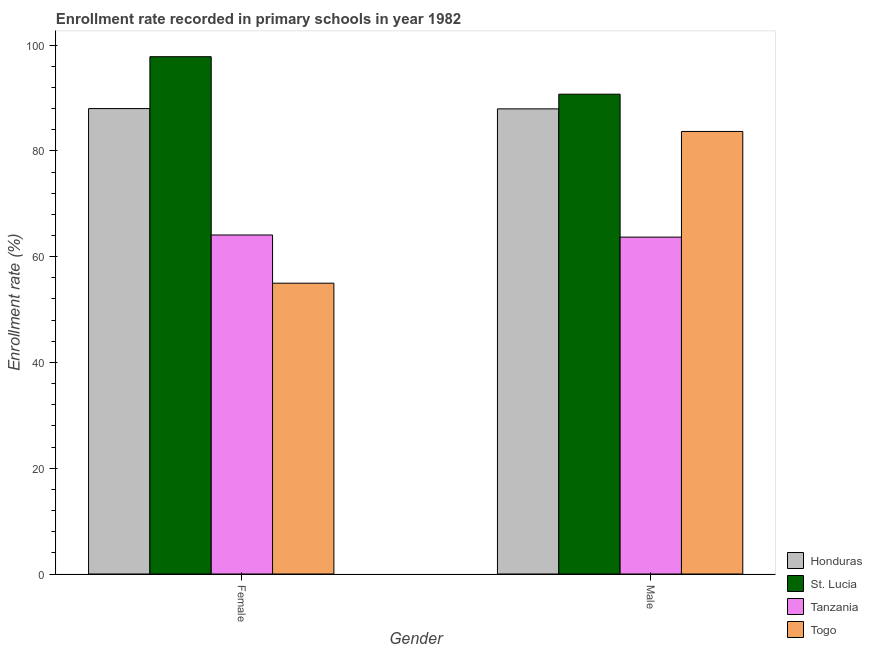Are the number of bars on each tick of the X-axis equal?
Provide a short and direct response. Yes. How many bars are there on the 2nd tick from the right?
Provide a short and direct response. 4. What is the label of the 1st group of bars from the left?
Your answer should be compact. Female. What is the enrollment rate of male students in Honduras?
Give a very brief answer. 87.95. Across all countries, what is the maximum enrollment rate of male students?
Make the answer very short. 90.72. Across all countries, what is the minimum enrollment rate of male students?
Offer a very short reply. 63.7. In which country was the enrollment rate of male students maximum?
Provide a succinct answer. St. Lucia. In which country was the enrollment rate of male students minimum?
Ensure brevity in your answer.  Tanzania. What is the total enrollment rate of male students in the graph?
Ensure brevity in your answer.  326.05. What is the difference between the enrollment rate of female students in St. Lucia and that in Togo?
Your response must be concise. 42.83. What is the difference between the enrollment rate of female students in Togo and the enrollment rate of male students in Honduras?
Make the answer very short. -32.96. What is the average enrollment rate of male students per country?
Offer a very short reply. 81.51. What is the difference between the enrollment rate of female students and enrollment rate of male students in Togo?
Provide a succinct answer. -28.69. What is the ratio of the enrollment rate of male students in Honduras to that in Tanzania?
Keep it short and to the point. 1.38. In how many countries, is the enrollment rate of female students greater than the average enrollment rate of female students taken over all countries?
Offer a very short reply. 2. What does the 4th bar from the left in Male represents?
Offer a terse response. Togo. What does the 4th bar from the right in Male represents?
Offer a very short reply. Honduras. Are all the bars in the graph horizontal?
Make the answer very short. No. How many countries are there in the graph?
Ensure brevity in your answer.  4. Are the values on the major ticks of Y-axis written in scientific E-notation?
Your answer should be compact. No. How many legend labels are there?
Offer a very short reply. 4. What is the title of the graph?
Provide a short and direct response. Enrollment rate recorded in primary schools in year 1982. What is the label or title of the X-axis?
Offer a terse response. Gender. What is the label or title of the Y-axis?
Provide a succinct answer. Enrollment rate (%). What is the Enrollment rate (%) in Honduras in Female?
Provide a short and direct response. 88. What is the Enrollment rate (%) of St. Lucia in Female?
Your answer should be very brief. 97.81. What is the Enrollment rate (%) in Tanzania in Female?
Offer a terse response. 64.1. What is the Enrollment rate (%) in Togo in Female?
Ensure brevity in your answer.  54.99. What is the Enrollment rate (%) in Honduras in Male?
Your response must be concise. 87.95. What is the Enrollment rate (%) in St. Lucia in Male?
Ensure brevity in your answer.  90.72. What is the Enrollment rate (%) in Tanzania in Male?
Ensure brevity in your answer.  63.7. What is the Enrollment rate (%) of Togo in Male?
Provide a short and direct response. 83.68. Across all Gender, what is the maximum Enrollment rate (%) of Honduras?
Your response must be concise. 88. Across all Gender, what is the maximum Enrollment rate (%) in St. Lucia?
Provide a short and direct response. 97.81. Across all Gender, what is the maximum Enrollment rate (%) of Tanzania?
Give a very brief answer. 64.1. Across all Gender, what is the maximum Enrollment rate (%) of Togo?
Provide a short and direct response. 83.68. Across all Gender, what is the minimum Enrollment rate (%) of Honduras?
Your answer should be very brief. 87.95. Across all Gender, what is the minimum Enrollment rate (%) in St. Lucia?
Offer a very short reply. 90.72. Across all Gender, what is the minimum Enrollment rate (%) of Tanzania?
Your answer should be very brief. 63.7. Across all Gender, what is the minimum Enrollment rate (%) of Togo?
Provide a short and direct response. 54.99. What is the total Enrollment rate (%) in Honduras in the graph?
Make the answer very short. 175.95. What is the total Enrollment rate (%) in St. Lucia in the graph?
Keep it short and to the point. 188.54. What is the total Enrollment rate (%) of Tanzania in the graph?
Your response must be concise. 127.8. What is the total Enrollment rate (%) in Togo in the graph?
Make the answer very short. 138.66. What is the difference between the Enrollment rate (%) in Honduras in Female and that in Male?
Offer a very short reply. 0.06. What is the difference between the Enrollment rate (%) in St. Lucia in Female and that in Male?
Make the answer very short. 7.09. What is the difference between the Enrollment rate (%) in Tanzania in Female and that in Male?
Give a very brief answer. 0.4. What is the difference between the Enrollment rate (%) in Togo in Female and that in Male?
Ensure brevity in your answer.  -28.69. What is the difference between the Enrollment rate (%) in Honduras in Female and the Enrollment rate (%) in St. Lucia in Male?
Ensure brevity in your answer.  -2.72. What is the difference between the Enrollment rate (%) in Honduras in Female and the Enrollment rate (%) in Tanzania in Male?
Your answer should be very brief. 24.31. What is the difference between the Enrollment rate (%) of Honduras in Female and the Enrollment rate (%) of Togo in Male?
Your answer should be compact. 4.33. What is the difference between the Enrollment rate (%) in St. Lucia in Female and the Enrollment rate (%) in Tanzania in Male?
Ensure brevity in your answer.  34.12. What is the difference between the Enrollment rate (%) in St. Lucia in Female and the Enrollment rate (%) in Togo in Male?
Keep it short and to the point. 14.14. What is the difference between the Enrollment rate (%) of Tanzania in Female and the Enrollment rate (%) of Togo in Male?
Provide a succinct answer. -19.58. What is the average Enrollment rate (%) in Honduras per Gender?
Give a very brief answer. 87.98. What is the average Enrollment rate (%) in St. Lucia per Gender?
Offer a terse response. 94.27. What is the average Enrollment rate (%) in Tanzania per Gender?
Provide a short and direct response. 63.9. What is the average Enrollment rate (%) in Togo per Gender?
Ensure brevity in your answer.  69.33. What is the difference between the Enrollment rate (%) in Honduras and Enrollment rate (%) in St. Lucia in Female?
Offer a very short reply. -9.81. What is the difference between the Enrollment rate (%) of Honduras and Enrollment rate (%) of Tanzania in Female?
Make the answer very short. 23.91. What is the difference between the Enrollment rate (%) of Honduras and Enrollment rate (%) of Togo in Female?
Offer a terse response. 33.02. What is the difference between the Enrollment rate (%) in St. Lucia and Enrollment rate (%) in Tanzania in Female?
Provide a short and direct response. 33.71. What is the difference between the Enrollment rate (%) in St. Lucia and Enrollment rate (%) in Togo in Female?
Ensure brevity in your answer.  42.83. What is the difference between the Enrollment rate (%) in Tanzania and Enrollment rate (%) in Togo in Female?
Provide a short and direct response. 9.11. What is the difference between the Enrollment rate (%) of Honduras and Enrollment rate (%) of St. Lucia in Male?
Your answer should be very brief. -2.78. What is the difference between the Enrollment rate (%) of Honduras and Enrollment rate (%) of Tanzania in Male?
Provide a succinct answer. 24.25. What is the difference between the Enrollment rate (%) in Honduras and Enrollment rate (%) in Togo in Male?
Provide a short and direct response. 4.27. What is the difference between the Enrollment rate (%) in St. Lucia and Enrollment rate (%) in Tanzania in Male?
Offer a terse response. 27.03. What is the difference between the Enrollment rate (%) in St. Lucia and Enrollment rate (%) in Togo in Male?
Provide a succinct answer. 7.05. What is the difference between the Enrollment rate (%) in Tanzania and Enrollment rate (%) in Togo in Male?
Your response must be concise. -19.98. What is the ratio of the Enrollment rate (%) in Honduras in Female to that in Male?
Your answer should be compact. 1. What is the ratio of the Enrollment rate (%) in St. Lucia in Female to that in Male?
Offer a very short reply. 1.08. What is the ratio of the Enrollment rate (%) in Tanzania in Female to that in Male?
Give a very brief answer. 1.01. What is the ratio of the Enrollment rate (%) of Togo in Female to that in Male?
Keep it short and to the point. 0.66. What is the difference between the highest and the second highest Enrollment rate (%) in Honduras?
Your answer should be compact. 0.06. What is the difference between the highest and the second highest Enrollment rate (%) in St. Lucia?
Make the answer very short. 7.09. What is the difference between the highest and the second highest Enrollment rate (%) in Tanzania?
Your answer should be compact. 0.4. What is the difference between the highest and the second highest Enrollment rate (%) in Togo?
Provide a short and direct response. 28.69. What is the difference between the highest and the lowest Enrollment rate (%) in Honduras?
Offer a very short reply. 0.06. What is the difference between the highest and the lowest Enrollment rate (%) in St. Lucia?
Offer a terse response. 7.09. What is the difference between the highest and the lowest Enrollment rate (%) of Tanzania?
Offer a terse response. 0.4. What is the difference between the highest and the lowest Enrollment rate (%) of Togo?
Offer a very short reply. 28.69. 